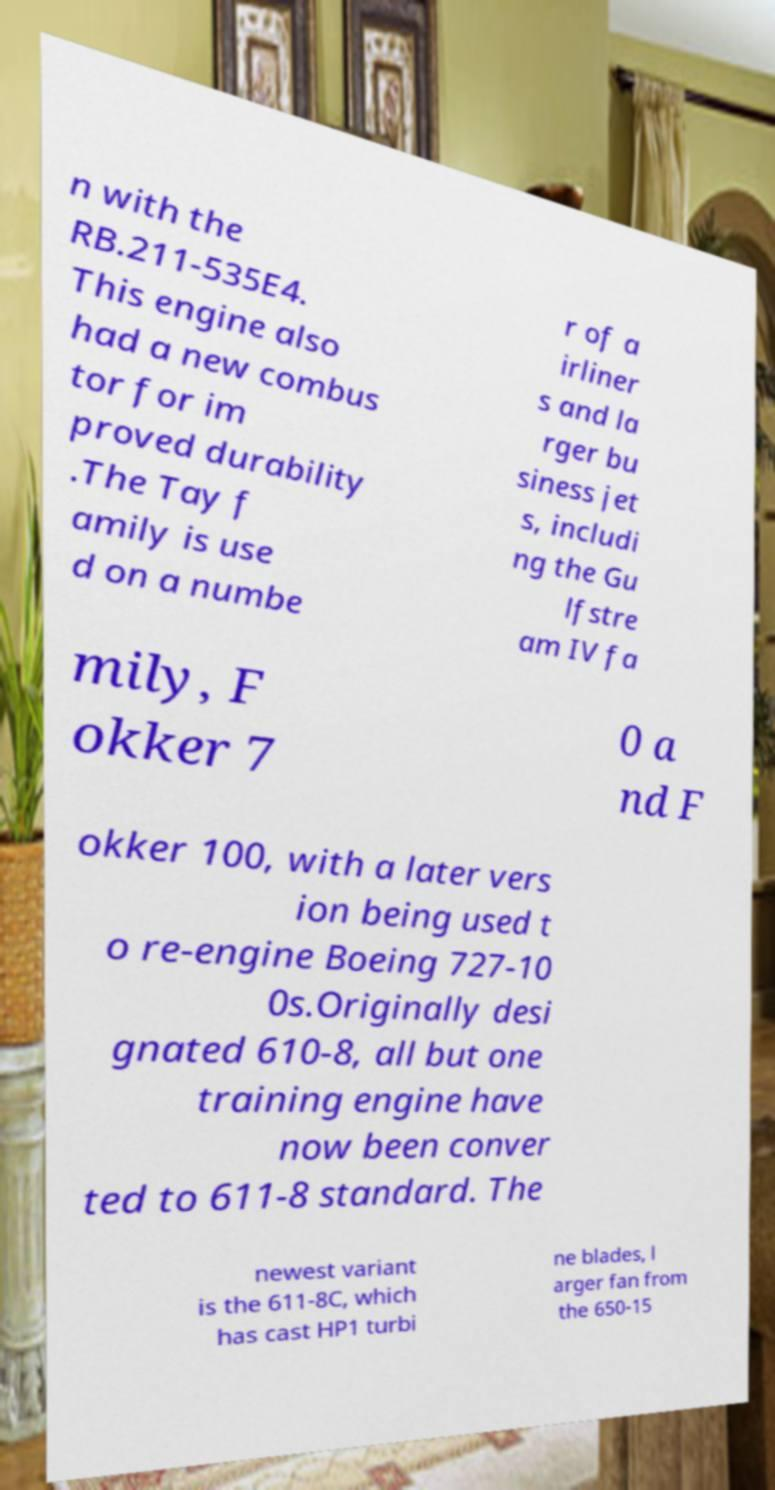Can you accurately transcribe the text from the provided image for me? n with the RB.211-535E4. This engine also had a new combus tor for im proved durability .The Tay f amily is use d on a numbe r of a irliner s and la rger bu siness jet s, includi ng the Gu lfstre am IV fa mily, F okker 7 0 a nd F okker 100, with a later vers ion being used t o re-engine Boeing 727-10 0s.Originally desi gnated 610-8, all but one training engine have now been conver ted to 611-8 standard. The newest variant is the 611-8C, which has cast HP1 turbi ne blades, l arger fan from the 650-15 